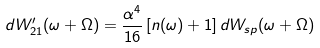<formula> <loc_0><loc_0><loc_500><loc_500>d W ^ { \prime } _ { 2 1 } ( \omega + \Omega ) = \frac { \alpha ^ { 4 } } { 1 6 } \left [ n ( \omega ) + 1 \right ] d W _ { s p } ( \omega + \Omega )</formula> 